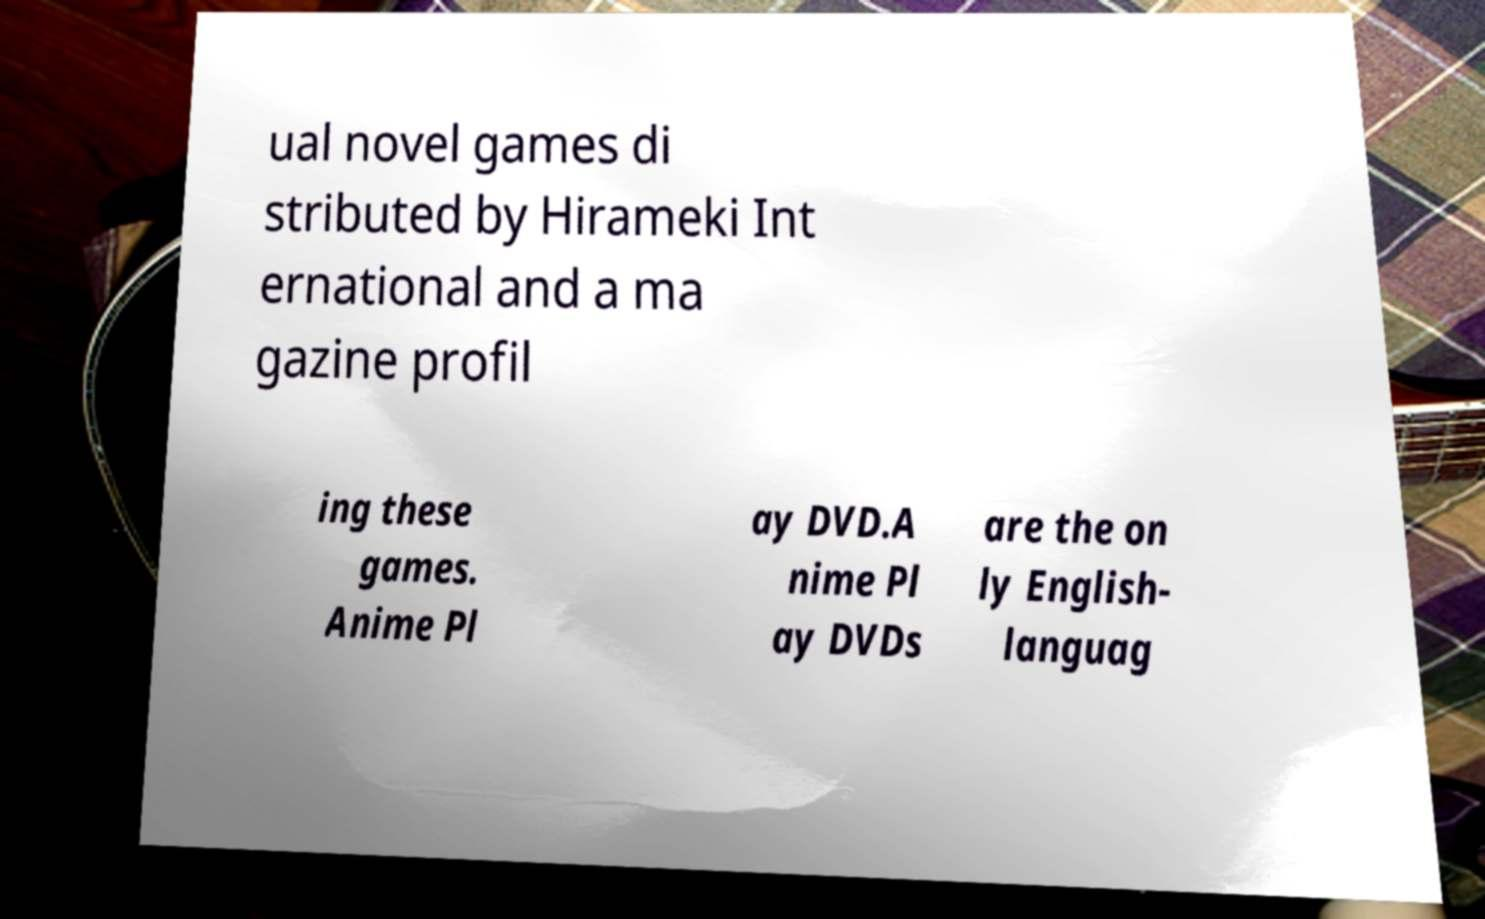Can you accurately transcribe the text from the provided image for me? ual novel games di stributed by Hirameki Int ernational and a ma gazine profil ing these games. Anime Pl ay DVD.A nime Pl ay DVDs are the on ly English- languag 